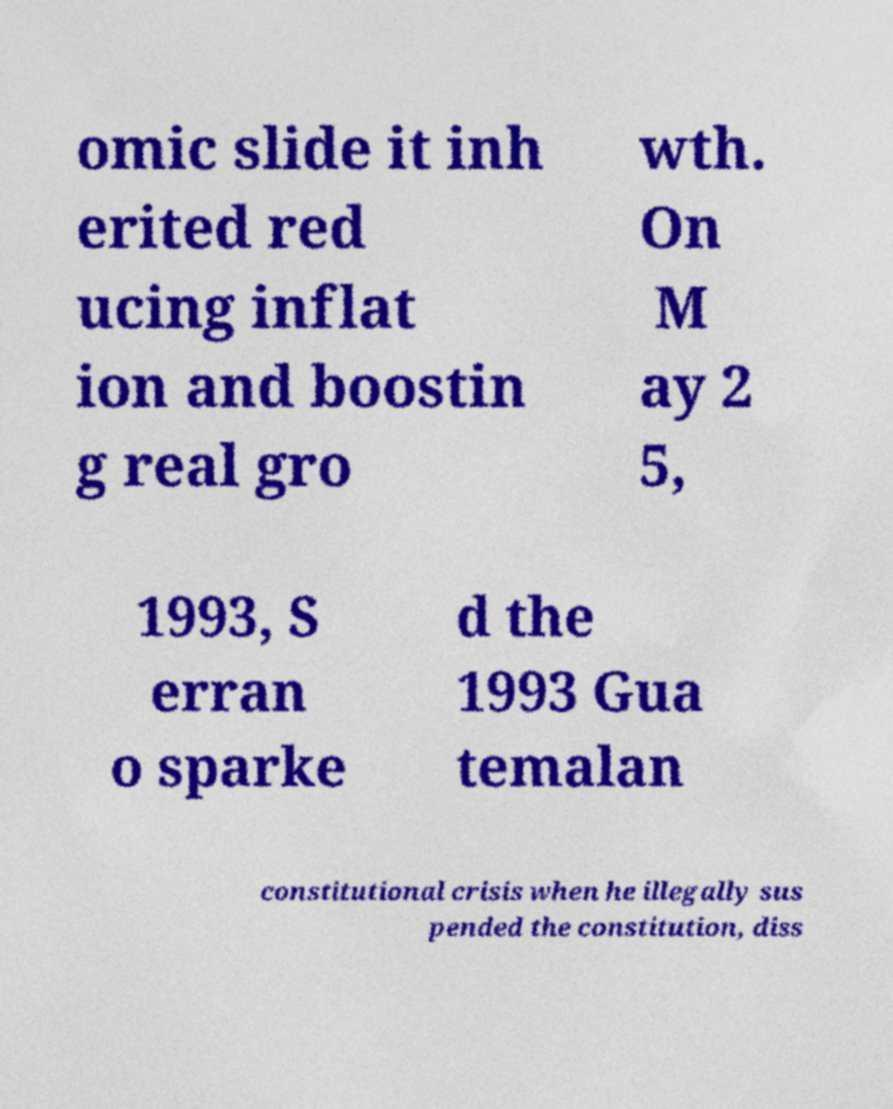Could you assist in decoding the text presented in this image and type it out clearly? omic slide it inh erited red ucing inflat ion and boostin g real gro wth. On M ay 2 5, 1993, S erran o sparke d the 1993 Gua temalan constitutional crisis when he illegally sus pended the constitution, diss 